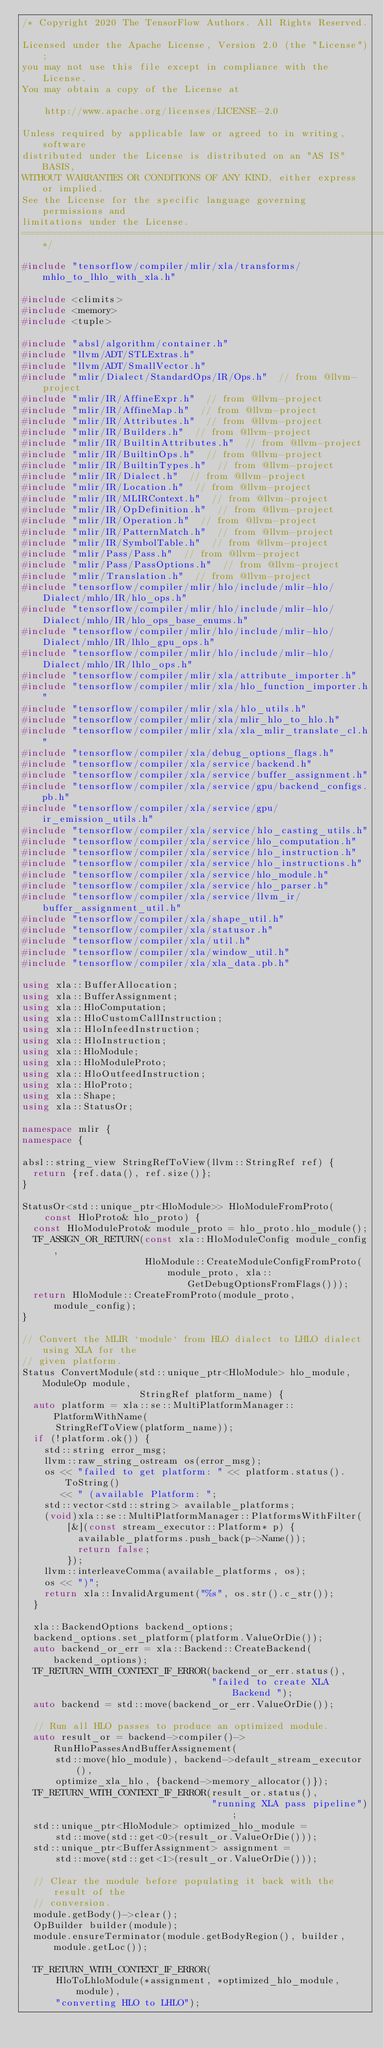Convert code to text. <code><loc_0><loc_0><loc_500><loc_500><_C++_>/* Copyright 2020 The TensorFlow Authors. All Rights Reserved.

Licensed under the Apache License, Version 2.0 (the "License");
you may not use this file except in compliance with the License.
You may obtain a copy of the License at

    http://www.apache.org/licenses/LICENSE-2.0

Unless required by applicable law or agreed to in writing, software
distributed under the License is distributed on an "AS IS" BASIS,
WITHOUT WARRANTIES OR CONDITIONS OF ANY KIND, either express or implied.
See the License for the specific language governing permissions and
limitations under the License.
==============================================================================*/

#include "tensorflow/compiler/mlir/xla/transforms/mhlo_to_lhlo_with_xla.h"

#include <climits>
#include <memory>
#include <tuple>

#include "absl/algorithm/container.h"
#include "llvm/ADT/STLExtras.h"
#include "llvm/ADT/SmallVector.h"
#include "mlir/Dialect/StandardOps/IR/Ops.h"  // from @llvm-project
#include "mlir/IR/AffineExpr.h"  // from @llvm-project
#include "mlir/IR/AffineMap.h"  // from @llvm-project
#include "mlir/IR/Attributes.h"  // from @llvm-project
#include "mlir/IR/Builders.h"  // from @llvm-project
#include "mlir/IR/BuiltinAttributes.h"  // from @llvm-project
#include "mlir/IR/BuiltinOps.h"  // from @llvm-project
#include "mlir/IR/BuiltinTypes.h"  // from @llvm-project
#include "mlir/IR/Dialect.h"  // from @llvm-project
#include "mlir/IR/Location.h"  // from @llvm-project
#include "mlir/IR/MLIRContext.h"  // from @llvm-project
#include "mlir/IR/OpDefinition.h"  // from @llvm-project
#include "mlir/IR/Operation.h"  // from @llvm-project
#include "mlir/IR/PatternMatch.h"  // from @llvm-project
#include "mlir/IR/SymbolTable.h"  // from @llvm-project
#include "mlir/Pass/Pass.h"  // from @llvm-project
#include "mlir/Pass/PassOptions.h"  // from @llvm-project
#include "mlir/Translation.h"  // from @llvm-project
#include "tensorflow/compiler/mlir/hlo/include/mlir-hlo/Dialect/mhlo/IR/hlo_ops.h"
#include "tensorflow/compiler/mlir/hlo/include/mlir-hlo/Dialect/mhlo/IR/hlo_ops_base_enums.h"
#include "tensorflow/compiler/mlir/hlo/include/mlir-hlo/Dialect/mhlo/IR/lhlo_gpu_ops.h"
#include "tensorflow/compiler/mlir/hlo/include/mlir-hlo/Dialect/mhlo/IR/lhlo_ops.h"
#include "tensorflow/compiler/mlir/xla/attribute_importer.h"
#include "tensorflow/compiler/mlir/xla/hlo_function_importer.h"
#include "tensorflow/compiler/mlir/xla/hlo_utils.h"
#include "tensorflow/compiler/mlir/xla/mlir_hlo_to_hlo.h"
#include "tensorflow/compiler/mlir/xla/xla_mlir_translate_cl.h"
#include "tensorflow/compiler/xla/debug_options_flags.h"
#include "tensorflow/compiler/xla/service/backend.h"
#include "tensorflow/compiler/xla/service/buffer_assignment.h"
#include "tensorflow/compiler/xla/service/gpu/backend_configs.pb.h"
#include "tensorflow/compiler/xla/service/gpu/ir_emission_utils.h"
#include "tensorflow/compiler/xla/service/hlo_casting_utils.h"
#include "tensorflow/compiler/xla/service/hlo_computation.h"
#include "tensorflow/compiler/xla/service/hlo_instruction.h"
#include "tensorflow/compiler/xla/service/hlo_instructions.h"
#include "tensorflow/compiler/xla/service/hlo_module.h"
#include "tensorflow/compiler/xla/service/hlo_parser.h"
#include "tensorflow/compiler/xla/service/llvm_ir/buffer_assignment_util.h"
#include "tensorflow/compiler/xla/shape_util.h"
#include "tensorflow/compiler/xla/statusor.h"
#include "tensorflow/compiler/xla/util.h"
#include "tensorflow/compiler/xla/window_util.h"
#include "tensorflow/compiler/xla/xla_data.pb.h"

using xla::BufferAllocation;
using xla::BufferAssignment;
using xla::HloComputation;
using xla::HloCustomCallInstruction;
using xla::HloInfeedInstruction;
using xla::HloInstruction;
using xla::HloModule;
using xla::HloModuleProto;
using xla::HloOutfeedInstruction;
using xla::HloProto;
using xla::Shape;
using xla::StatusOr;

namespace mlir {
namespace {

absl::string_view StringRefToView(llvm::StringRef ref) {
  return {ref.data(), ref.size()};
}

StatusOr<std::unique_ptr<HloModule>> HloModuleFromProto(
    const HloProto& hlo_proto) {
  const HloModuleProto& module_proto = hlo_proto.hlo_module();
  TF_ASSIGN_OR_RETURN(const xla::HloModuleConfig module_config,
                      HloModule::CreateModuleConfigFromProto(
                          module_proto, xla::GetDebugOptionsFromFlags()));
  return HloModule::CreateFromProto(module_proto, module_config);
}

// Convert the MLIR `module` from HLO dialect to LHLO dialect using XLA for the
// given platform.
Status ConvertModule(std::unique_ptr<HloModule> hlo_module, ModuleOp module,
                     StringRef platform_name) {
  auto platform = xla::se::MultiPlatformManager::PlatformWithName(
      StringRefToView(platform_name));
  if (!platform.ok()) {
    std::string error_msg;
    llvm::raw_string_ostream os(error_msg);
    os << "failed to get platform: " << platform.status().ToString()
       << " (available Platform: ";
    std::vector<std::string> available_platforms;
    (void)xla::se::MultiPlatformManager::PlatformsWithFilter(
        [&](const stream_executor::Platform* p) {
          available_platforms.push_back(p->Name());
          return false;
        });
    llvm::interleaveComma(available_platforms, os);
    os << ")";
    return xla::InvalidArgument("%s", os.str().c_str());
  }

  xla::BackendOptions backend_options;
  backend_options.set_platform(platform.ValueOrDie());
  auto backend_or_err = xla::Backend::CreateBackend(backend_options);
  TF_RETURN_WITH_CONTEXT_IF_ERROR(backend_or_err.status(),
                                  "failed to create XLA Backend ");
  auto backend = std::move(backend_or_err.ValueOrDie());

  // Run all HLO passes to produce an optimized module.
  auto result_or = backend->compiler()->RunHloPassesAndBufferAssignement(
      std::move(hlo_module), backend->default_stream_executor(),
      optimize_xla_hlo, {backend->memory_allocator()});
  TF_RETURN_WITH_CONTEXT_IF_ERROR(result_or.status(),
                                  "running XLA pass pipeline");
  std::unique_ptr<HloModule> optimized_hlo_module =
      std::move(std::get<0>(result_or.ValueOrDie()));
  std::unique_ptr<BufferAssignment> assignment =
      std::move(std::get<1>(result_or.ValueOrDie()));

  // Clear the module before populating it back with the result of the
  // conversion.
  module.getBody()->clear();
  OpBuilder builder(module);
  module.ensureTerminator(module.getBodyRegion(), builder, module.getLoc());

  TF_RETURN_WITH_CONTEXT_IF_ERROR(
      HloToLhloModule(*assignment, *optimized_hlo_module, module),
      "converting HLO to LHLO");
</code> 